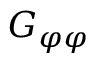Convert formula to latex. <formula><loc_0><loc_0><loc_500><loc_500>G _ { \varphi \varphi }</formula> 